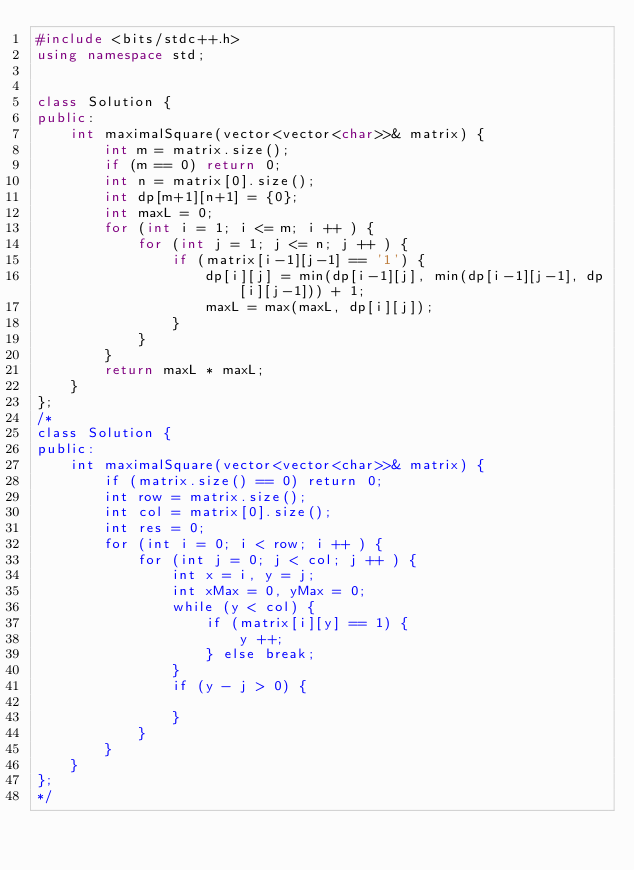Convert code to text. <code><loc_0><loc_0><loc_500><loc_500><_C++_>#include <bits/stdc++.h>
using namespace std;


class Solution {
public:
    int maximalSquare(vector<vector<char>>& matrix) {
        int m = matrix.size();
        if (m == 0) return 0;
        int n = matrix[0].size();
        int dp[m+1][n+1] = {0};
        int maxL = 0;
        for (int i = 1; i <= m; i ++ ) {
            for (int j = 1; j <= n; j ++ ) {
                if (matrix[i-1][j-1] == '1') {
                    dp[i][j] = min(dp[i-1][j], min(dp[i-1][j-1], dp[i][j-1])) + 1;
                    maxL = max(maxL, dp[i][j]);
                }
            }
        }
        return maxL * maxL;
    }
};
/* 
class Solution {
public:
    int maximalSquare(vector<vector<char>>& matrix) {
        if (matrix.size() == 0) return 0;
        int row = matrix.size();
        int col = matrix[0].size();
        int res = 0;
        for (int i = 0; i < row; i ++ ) {
            for (int j = 0; j < col; j ++ ) {
                int x = i, y = j;
                int xMax = 0, yMax = 0;
                while (y < col) {
                    if (matrix[i][y] == 1) {
                        y ++;
                    } else break;
                }
                if (y - j > 0) {
                    
                }
            }
        }
    }
};
*/</code> 